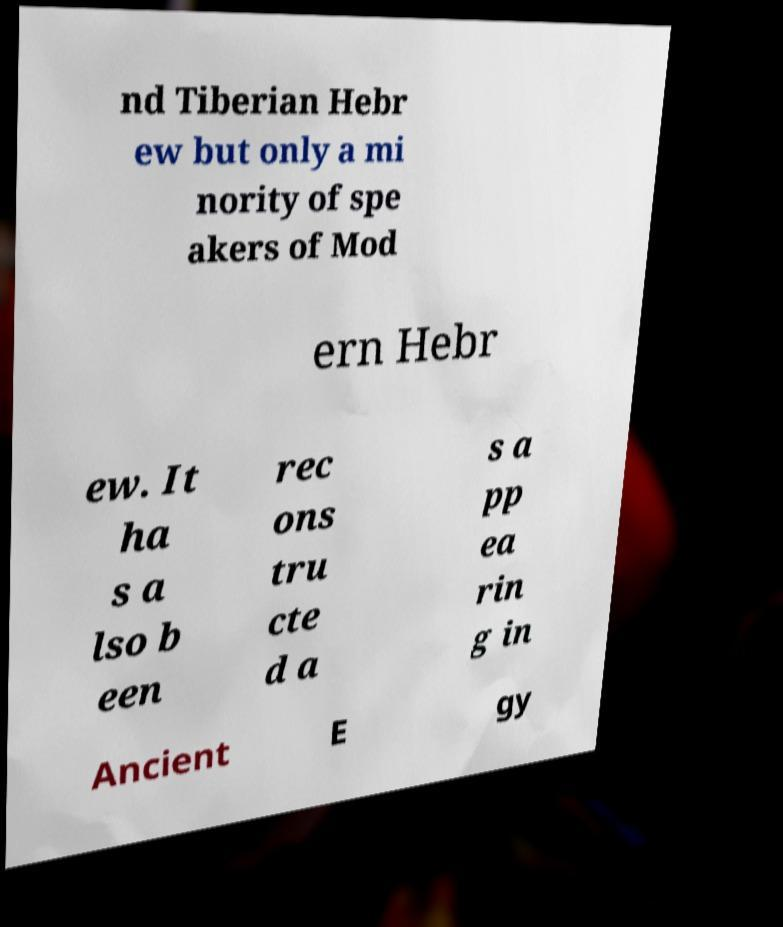I need the written content from this picture converted into text. Can you do that? nd Tiberian Hebr ew but only a mi nority of spe akers of Mod ern Hebr ew. It ha s a lso b een rec ons tru cte d a s a pp ea rin g in Ancient E gy 